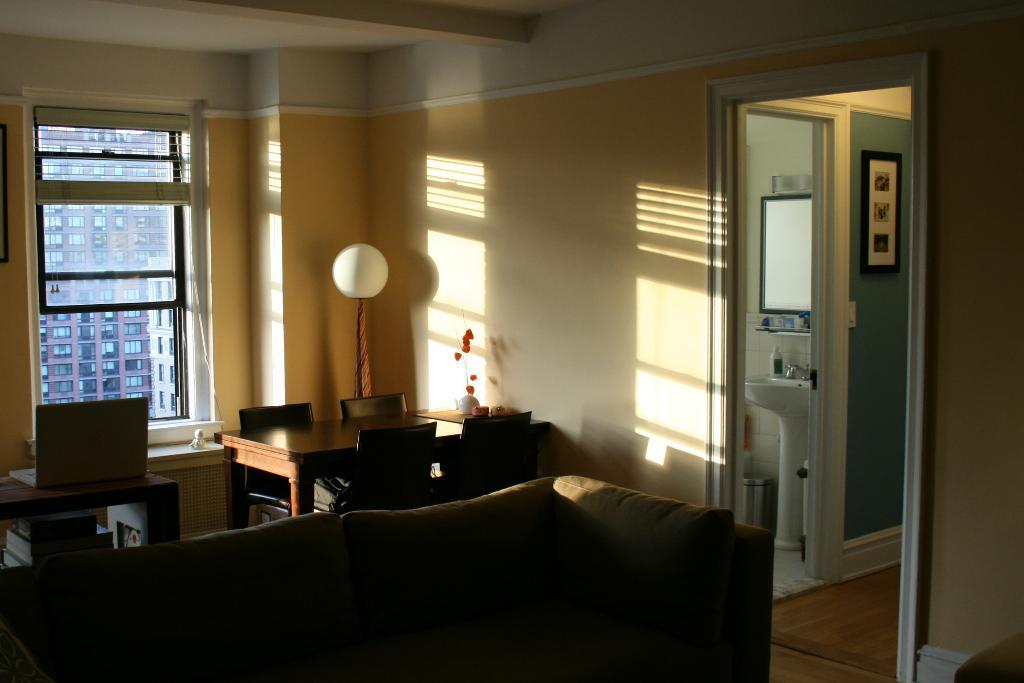What type of furniture is present in the image? There is a couch, a table, and chairs in the image. What is on the table in the image? There is a laptop on the table in the image. What can be seen in the background of the image? There is a window in the background of the image. Where is the sink located in relation to the image? The sink is to the right of the image. What is hanging on the wall in the image? There is a frame on the wall in the image. What type of business is being conducted in the image? There is no indication of any business being conducted in the image. What list can be seen on the table in the image? There is no list present on the table in the image. 